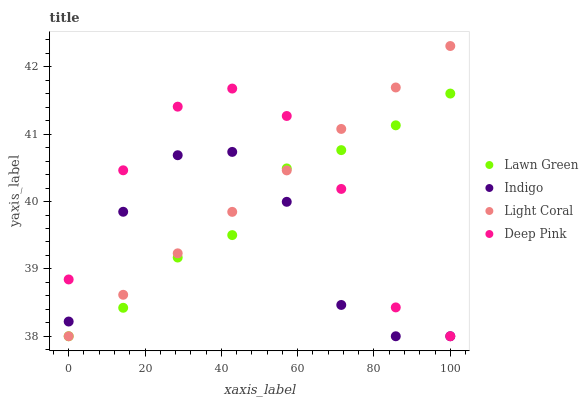Does Indigo have the minimum area under the curve?
Answer yes or no. Yes. Does Deep Pink have the maximum area under the curve?
Answer yes or no. Yes. Does Lawn Green have the minimum area under the curve?
Answer yes or no. No. Does Lawn Green have the maximum area under the curve?
Answer yes or no. No. Is Light Coral the smoothest?
Answer yes or no. Yes. Is Deep Pink the roughest?
Answer yes or no. Yes. Is Lawn Green the smoothest?
Answer yes or no. No. Is Lawn Green the roughest?
Answer yes or no. No. Does Light Coral have the lowest value?
Answer yes or no. Yes. Does Light Coral have the highest value?
Answer yes or no. Yes. Does Lawn Green have the highest value?
Answer yes or no. No. Does Lawn Green intersect Light Coral?
Answer yes or no. Yes. Is Lawn Green less than Light Coral?
Answer yes or no. No. Is Lawn Green greater than Light Coral?
Answer yes or no. No. 